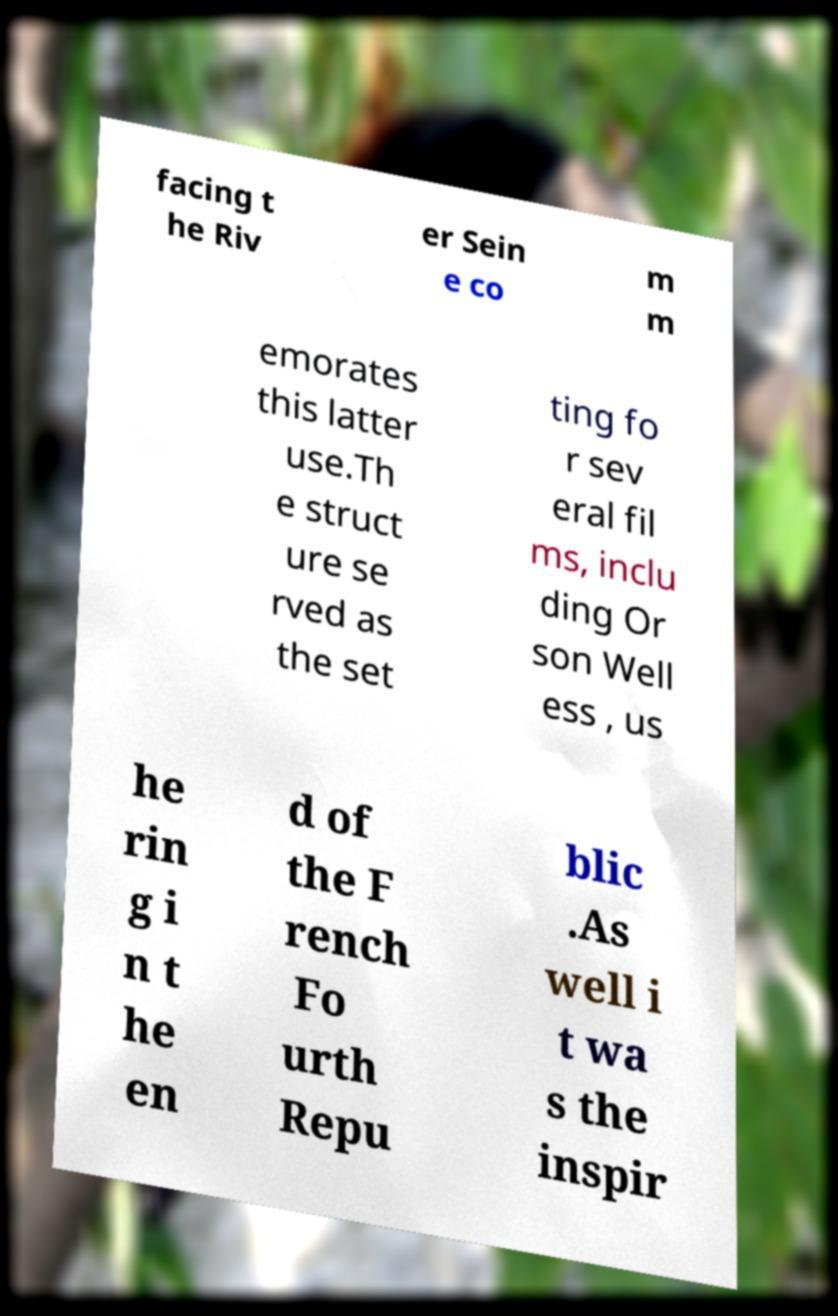Could you assist in decoding the text presented in this image and type it out clearly? facing t he Riv er Sein e co m m emorates this latter use.Th e struct ure se rved as the set ting fo r sev eral fil ms, inclu ding Or son Well ess , us he rin g i n t he en d of the F rench Fo urth Repu blic .As well i t wa s the inspir 